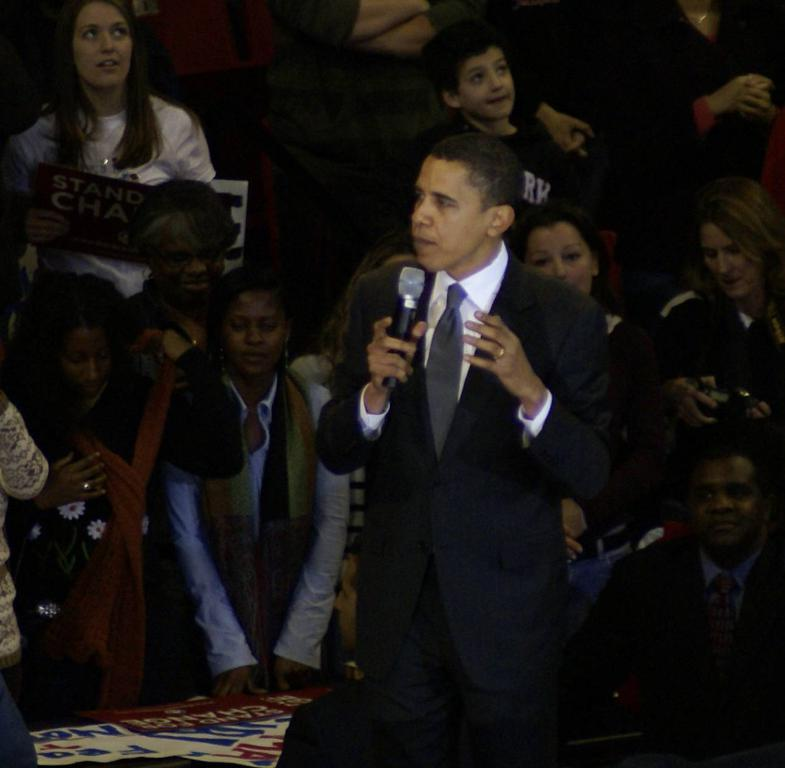What is the man in the image doing? The man is standing in the image and holding a microphone. Can you describe the people in the background of the image? There are people standing in the background of the image. What is the man's opinion on the motion of the sink in the image? There is no sink present in the image, so it is not possible to determine the man's opinion on the motion of a sink. 